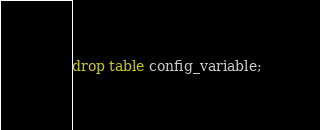<code> <loc_0><loc_0><loc_500><loc_500><_SQL_>drop table config_variable;</code> 